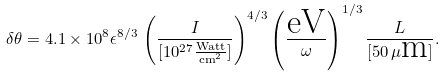<formula> <loc_0><loc_0><loc_500><loc_500>\delta \theta = 4 . 1 \times 1 0 ^ { 8 } \epsilon ^ { 8 / 3 } \, \left ( \frac { I } { [ 1 0 ^ { 2 7 } \frac { \text {Watt} } { \text {cm} ^ { 2 } } ] } \right ) ^ { 4 / 3 } \left ( \frac { \text {eV} } { \omega } \right ) ^ { 1 / 3 } \frac { L } { [ 5 0 \, \mu \text {m} ] } .</formula> 